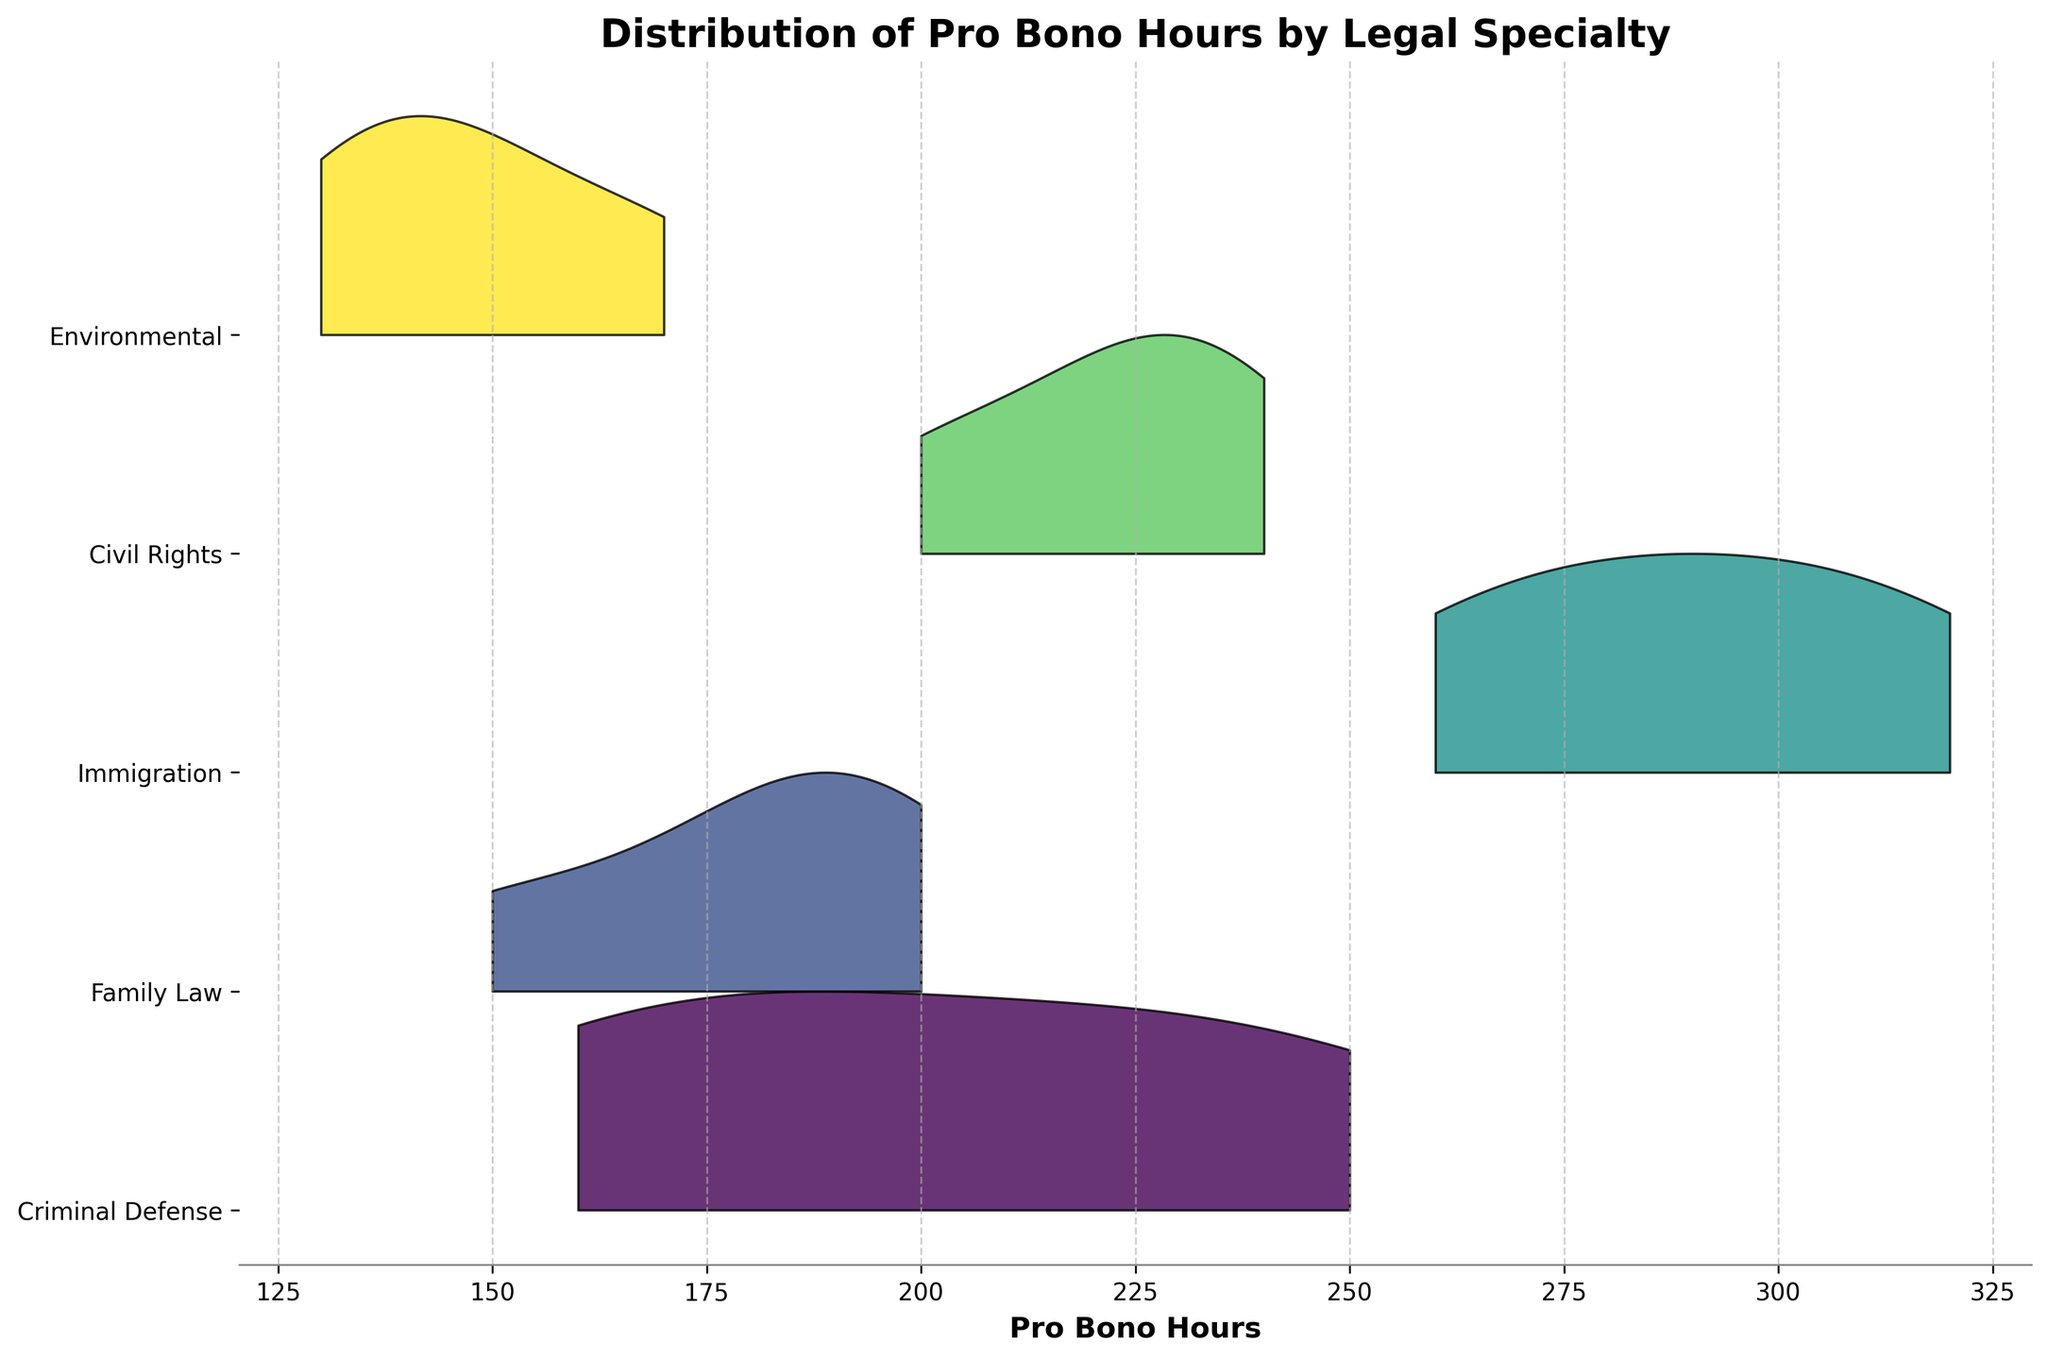What's the title of the plot? The title is located at the top of the figure in bold text. By looking at the figure, we can see the exact words written as the title.
Answer: Distribution of Pro Bono Hours by Legal Specialty What is the x-axis label? The x-axis label is usually placed directly under the x-axis. From the figure, we can read it to find the exact phrase used.
Answer: Pro Bono Hours How many legal specialties are represented in the plot? We can count the number of unique labels on the y-axis to determine the number of legal specialties.
Answer: 5 Which legal specialty has the highest range of pro bono hours? The range for each specialty can be determined by observing how the distribution spreads along the x-axis, noting the minimum and maximum points. The specialty with the widest spread has the highest range.
Answer: Immigration What is the general trend in the pro bono hours for Environmental law compared to Civil Rights law? Comparing Environmental and Civil Rights distributions, we can see which of them generally has higher or lower pro bono hours by observing the spread and peaks.
Answer: Environmental law generally has fewer hours than Civil Rights law Which legal specialty shows the least variation in pro bono hours? The specialty with the narrowest spread in its distribution along the x-axis has the least variation. Less spread means less variation in the dataset.
Answer: Environmental How do the pro bono hours for Family Law compare to those for Criminal Defense? By examining the distributions and their positions on the x-axis, we can determine if Family Law generally has more, less, or similar pro bono hours compared to Criminal Defense.
Answer: Family Law generally has fewer hours than Criminal Defense What is the most common range of pro bono hours for Immigration law? The most common range can be determined by observing where the peak of the distribution occurs along the x-axis for Immigration law.
Answer: Between 280 and 320 hours Which law firm appears to be most consistent across all specialties in terms of pro bono hours? Consistency can be assessed by checking how similar the distributions are across different specialties for each firm.
Answer: Greenberg Traurig What percentage of the specialties show a peak of pro bono hours above 200? We need to count the number of specialties where the peak is located above 200 hours and then divide it by the total number of specialties, multiplying by 100 for the percentage.
Answer: 80% 